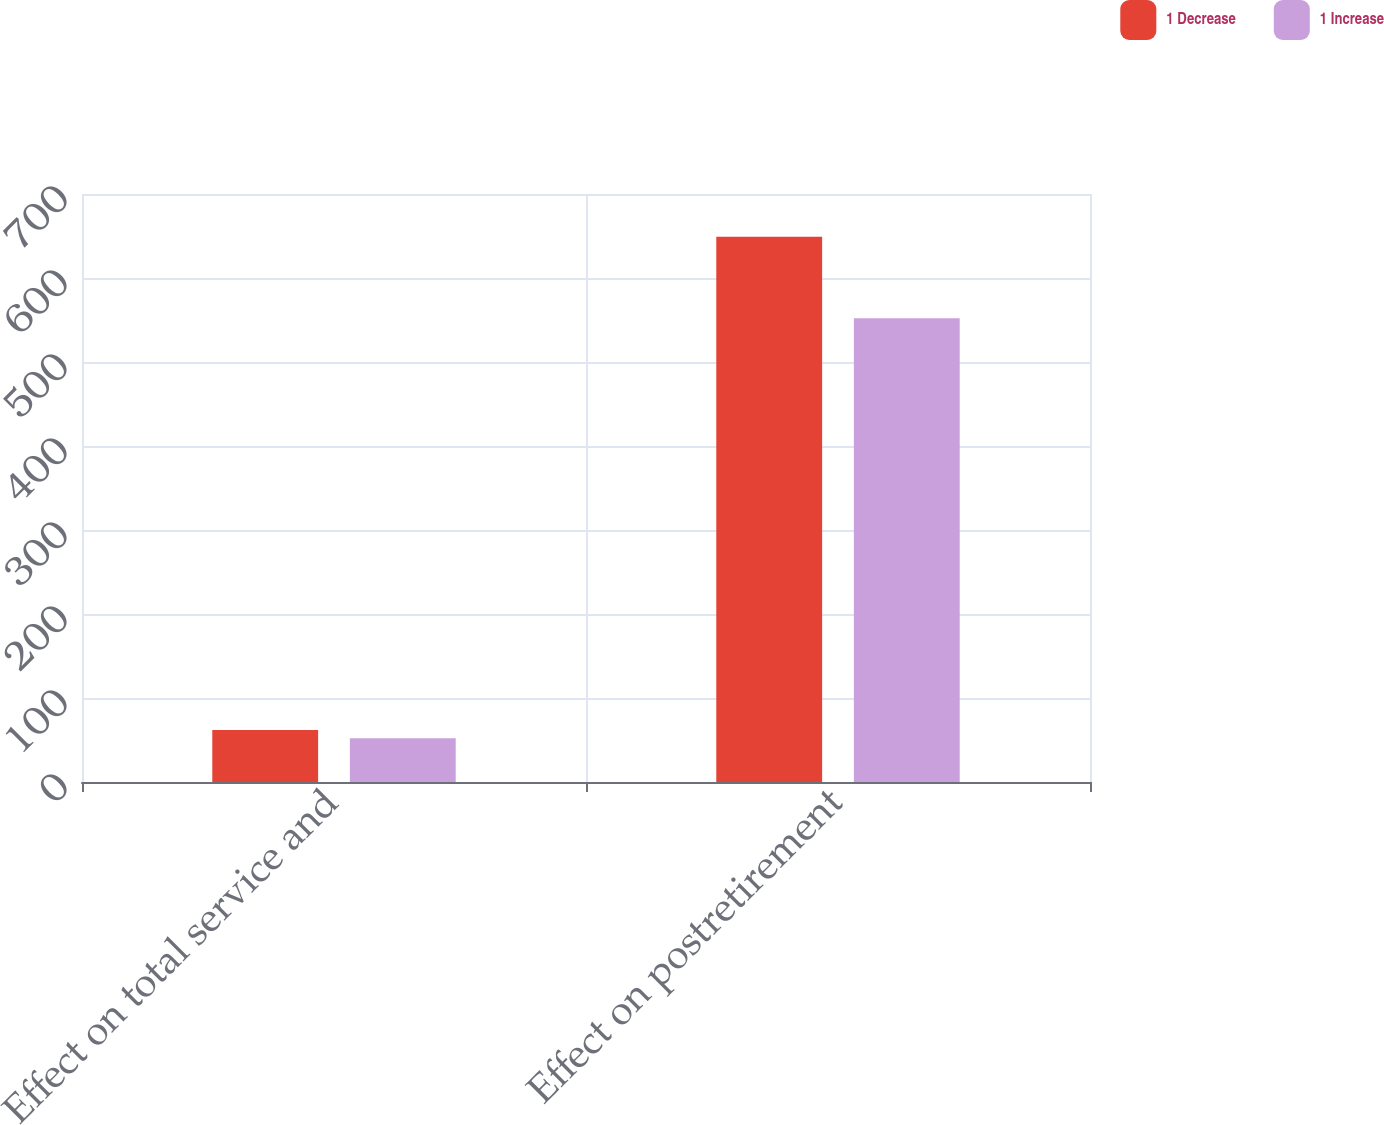<chart> <loc_0><loc_0><loc_500><loc_500><stacked_bar_chart><ecel><fcel>Effect on total service and<fcel>Effect on postretirement<nl><fcel>1 Decrease<fcel>62<fcel>649<nl><fcel>1 Increase<fcel>52<fcel>552<nl></chart> 